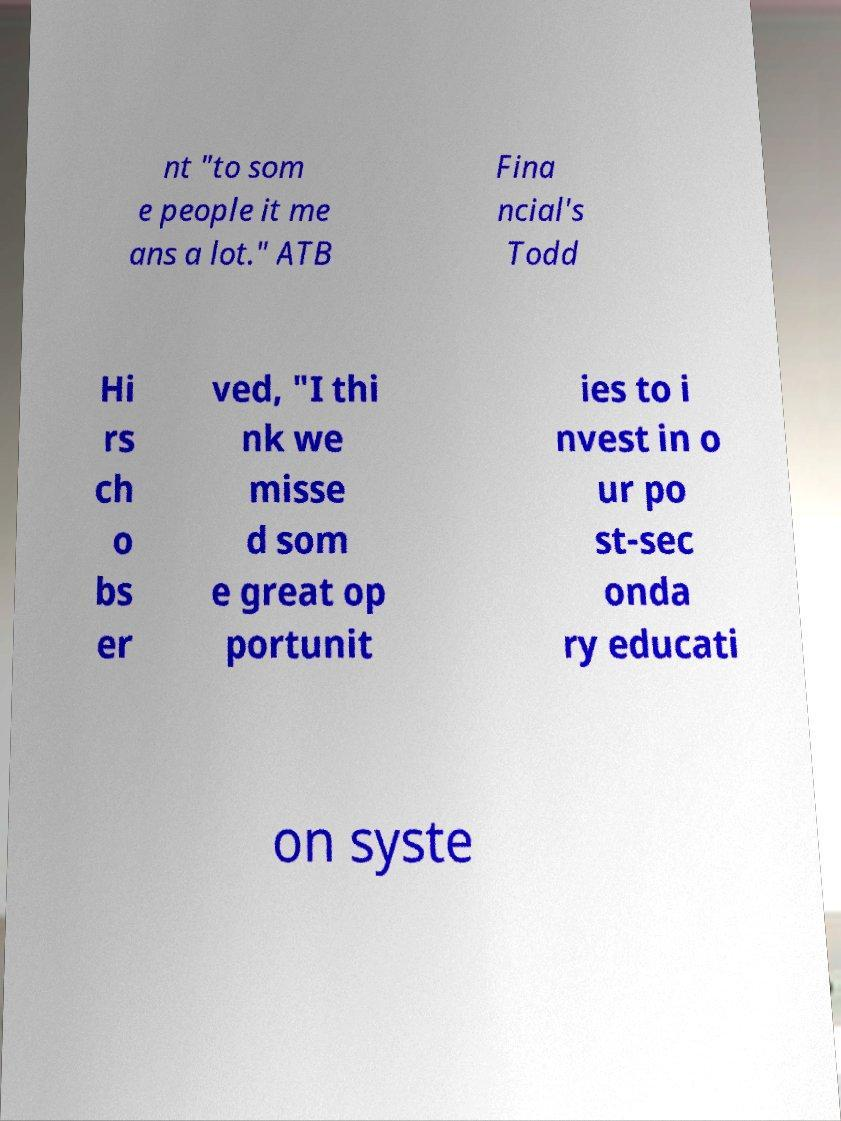Please identify and transcribe the text found in this image. nt "to som e people it me ans a lot." ATB Fina ncial's Todd Hi rs ch o bs er ved, "I thi nk we misse d som e great op portunit ies to i nvest in o ur po st-sec onda ry educati on syste 